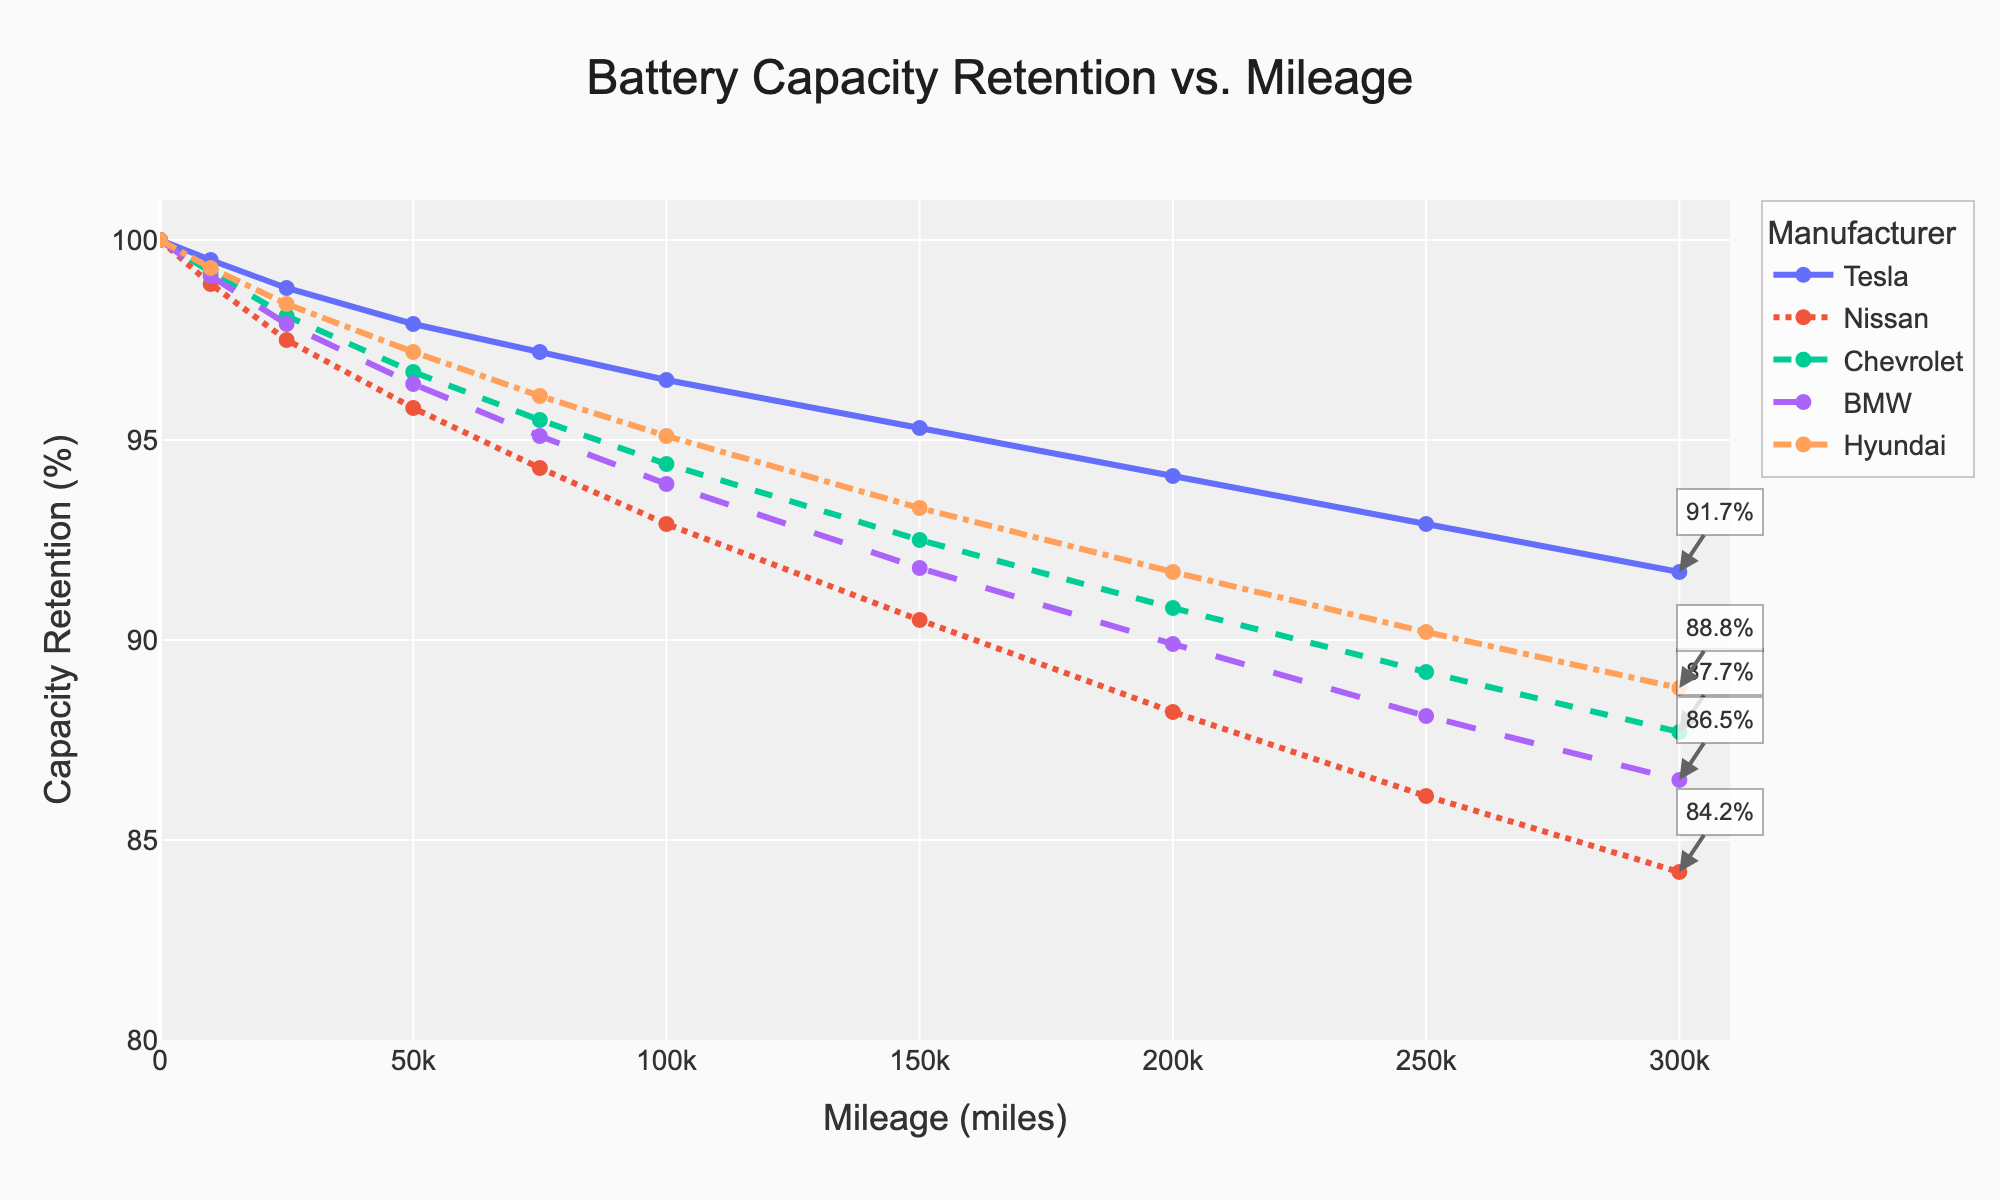What is the capacity retention of Tesla's battery at 200,000 miles? Look for the data point on the Tesla curve at 200,000 miles, which is approximately 94.1%.
Answer: 94.1% Which manufacturer shows the steepest decline in battery capacity retention as mileage increases? Compare the slope of the lines for all manufacturers. Nissan's line shows the steepest decline, indicating a rapid decrease in battery performance.
Answer: Nissan At what mileage do Hyundai's and BMW's batteries have approximately the same capacity retention? Find the point where the Hyundai and BMW lines cross. They cross at around 250,000 miles.
Answer: 250,000 miles How does the capacity retention of Chevrolet's battery at 100,000 miles compare to Nissan's at the same mileage? Look at the values on the Chevrolet and Nissan curves at 100,000 miles. Chevrolet's capacity retention is 94.4%, while Nissan's is 92.9%.
Answer: Chevrolet’s is higher by 1.5 percentage points Which manufacturer retains over 90% battery capacity for the longest mileage? Identify the manufacturer whose line stays above the 90% capacity retention mark for the longest distance. Tesla retains over 90% battery capacity up to approximately 300,000 miles.
Answer: Tesla What is the difference in capacity retention between Tesla and BMW at 150,000 miles? Locate the capacity retention values for Tesla and BMW at 150,000 miles: Tesla is around 95.3%, and BMW is around 91.8%, so the difference is 95.3% - 91.8% = 3.5%.
Answer: 3.5% Which two manufacturers' trends are the closest to each other in terms of capacity retention from 0 to 100,000 miles? Examine the proximity of the curves for each manufacturer between 0 and 100,000 miles. Hyundai and Chevrolet have similar trends in this range.
Answer: Hyundai and Chevrolet What is the average capacity retention for all manufacturers at 200,000 miles? Average the capacity retention values for Tesla (94.1%), Nissan (88.2%), Chevrolet (90.8%), BMW (89.9%), and Hyundai (91.7%): (94.1 + 88.2 + 90.8 + 89.9 + 91.7) / 5 = 90.94%.
Answer: 90.94% At what mileage does Nissan's battery capacity first drop below 90%? Identify the point on the Nissan line where capacity drops below 90%. This occurs just after 150,000 miles.
Answer: Just after 150,000 miles Based on the visual slope of the lines, which manufacturer appears to have the most gradual degradation in battery capacity? Compare the gradients of the lines. Tesla’s line appears to have the most gradual slope, indicating slower degradation.
Answer: Tesla 